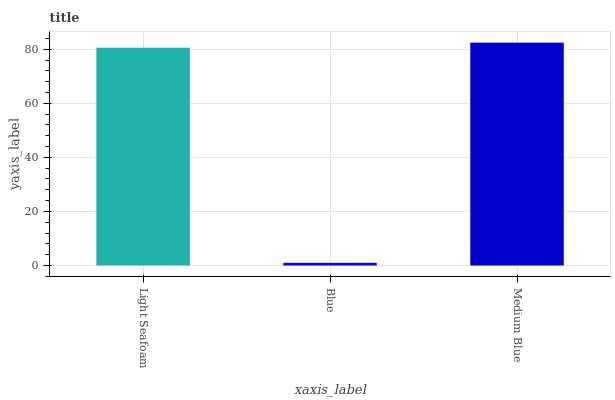Is Blue the minimum?
Answer yes or no. Yes. Is Medium Blue the maximum?
Answer yes or no. Yes. Is Medium Blue the minimum?
Answer yes or no. No. Is Blue the maximum?
Answer yes or no. No. Is Medium Blue greater than Blue?
Answer yes or no. Yes. Is Blue less than Medium Blue?
Answer yes or no. Yes. Is Blue greater than Medium Blue?
Answer yes or no. No. Is Medium Blue less than Blue?
Answer yes or no. No. Is Light Seafoam the high median?
Answer yes or no. Yes. Is Light Seafoam the low median?
Answer yes or no. Yes. Is Blue the high median?
Answer yes or no. No. Is Blue the low median?
Answer yes or no. No. 